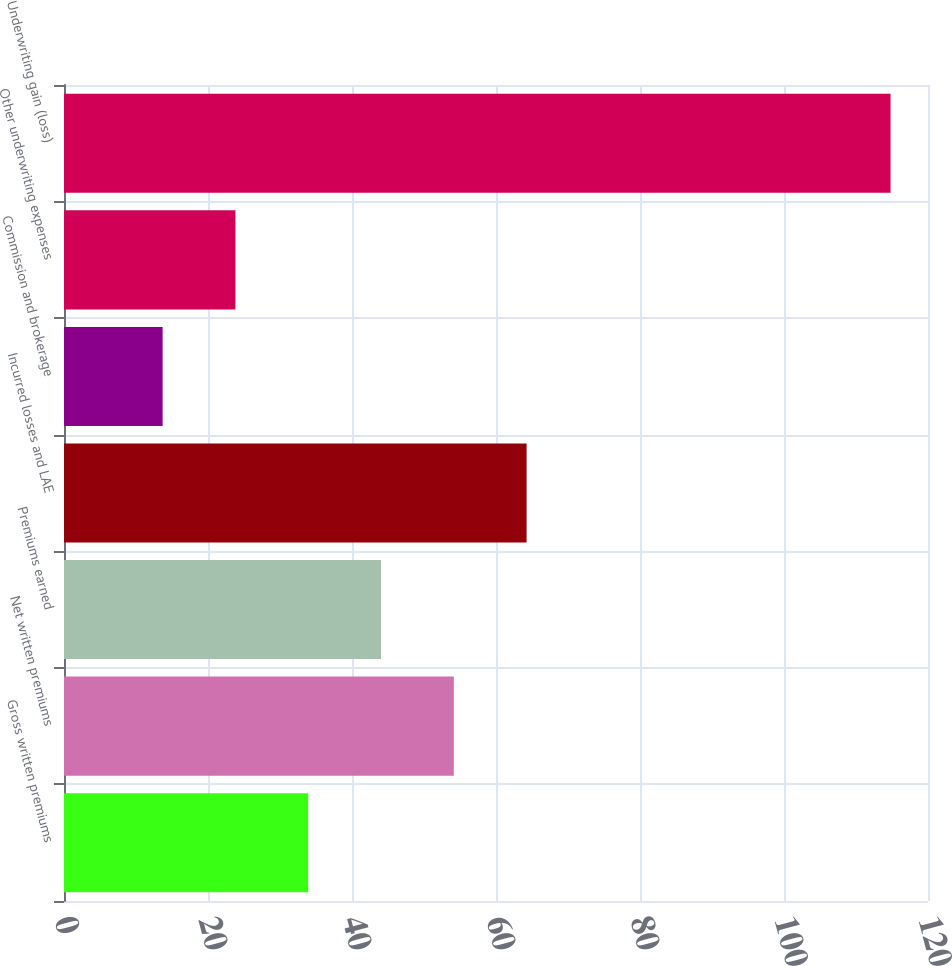Convert chart to OTSL. <chart><loc_0><loc_0><loc_500><loc_500><bar_chart><fcel>Gross written premiums<fcel>Net written premiums<fcel>Premiums earned<fcel>Incurred losses and LAE<fcel>Commission and brokerage<fcel>Other underwriting expenses<fcel>Underwriting gain (loss)<nl><fcel>33.92<fcel>54.14<fcel>44.03<fcel>64.25<fcel>13.7<fcel>23.81<fcel>114.8<nl></chart> 